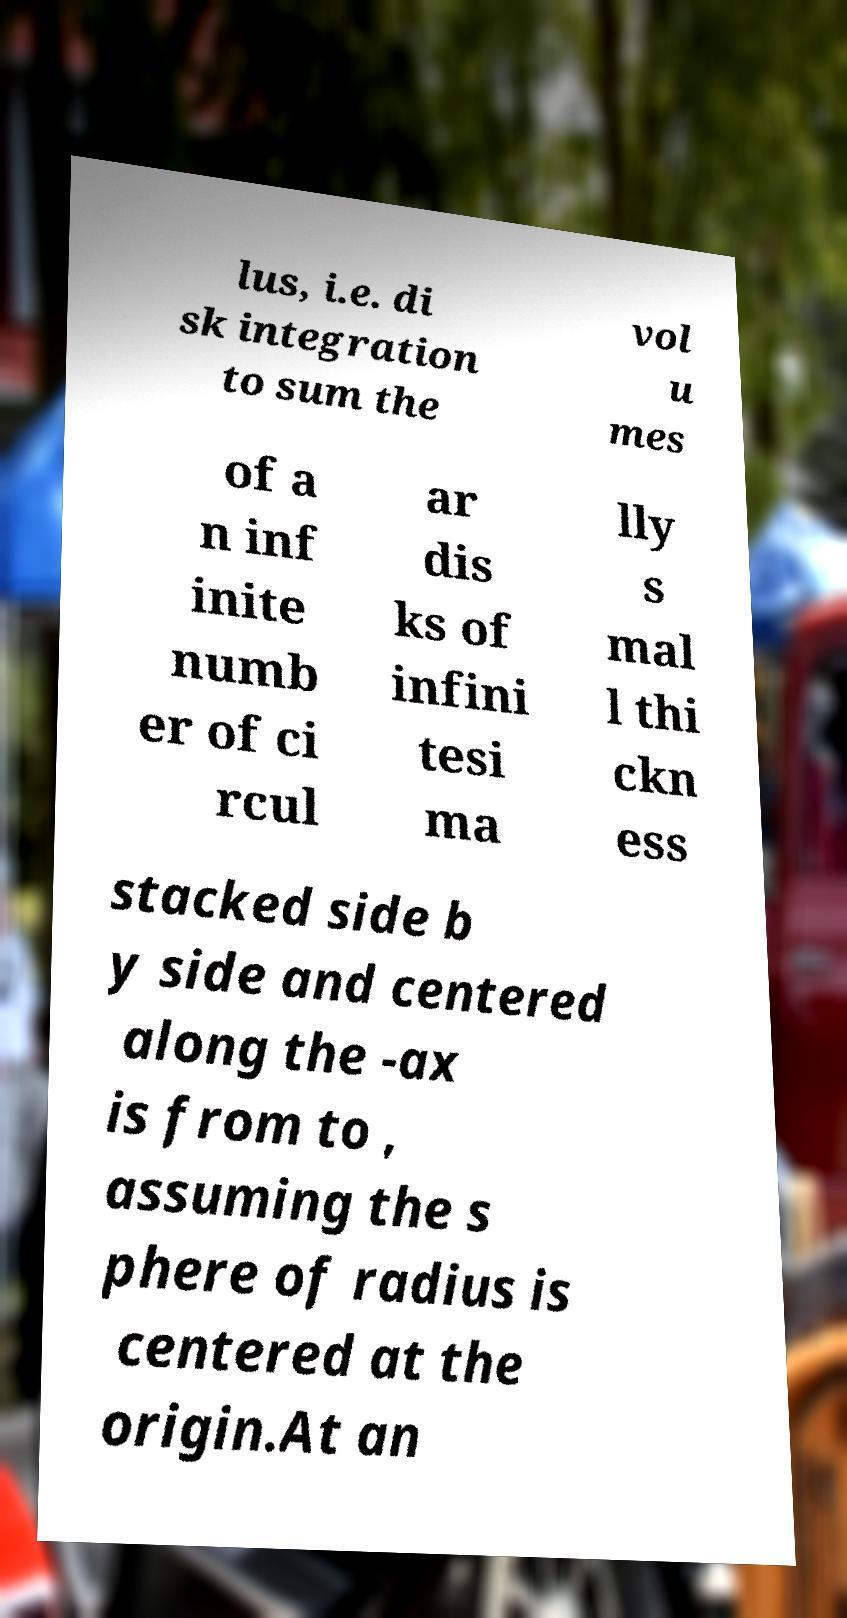Please read and relay the text visible in this image. What does it say? lus, i.e. di sk integration to sum the vol u mes of a n inf inite numb er of ci rcul ar dis ks of infini tesi ma lly s mal l thi ckn ess stacked side b y side and centered along the -ax is from to , assuming the s phere of radius is centered at the origin.At an 